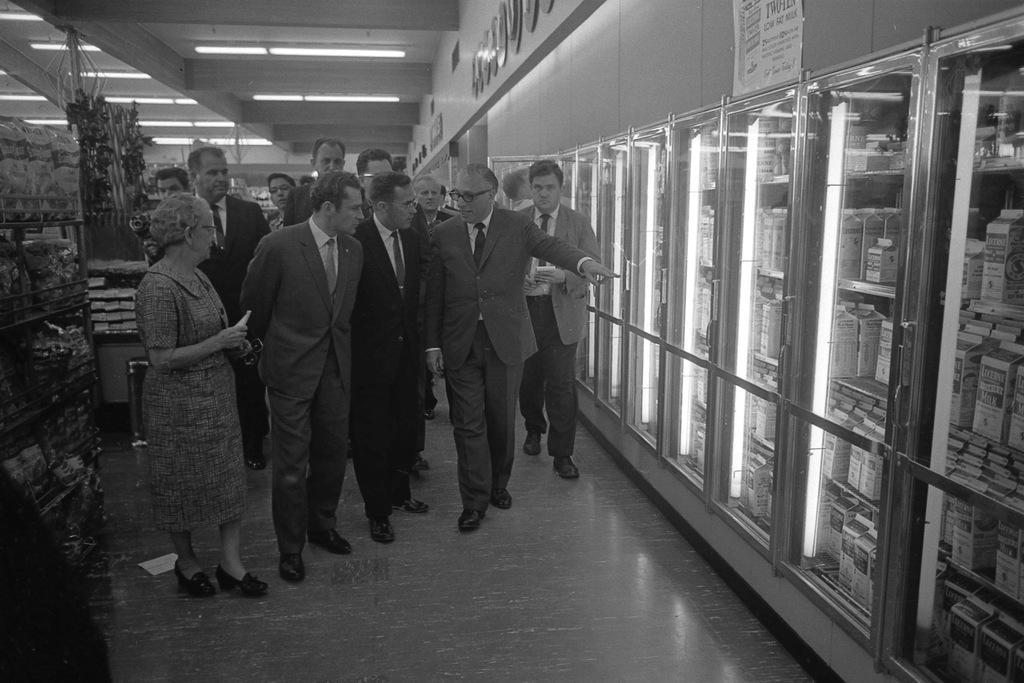In one or two sentences, can you explain what this image depicts? This picture is in black and white. In the center, there are group of people. All the men in the picture are wearing blazers. Towards the left, there is a woman. Towards the right, there are refrigerators. In the refrigerators, there are boxes. On the top, there are tube lights. Towards the left corner, there are racks. 